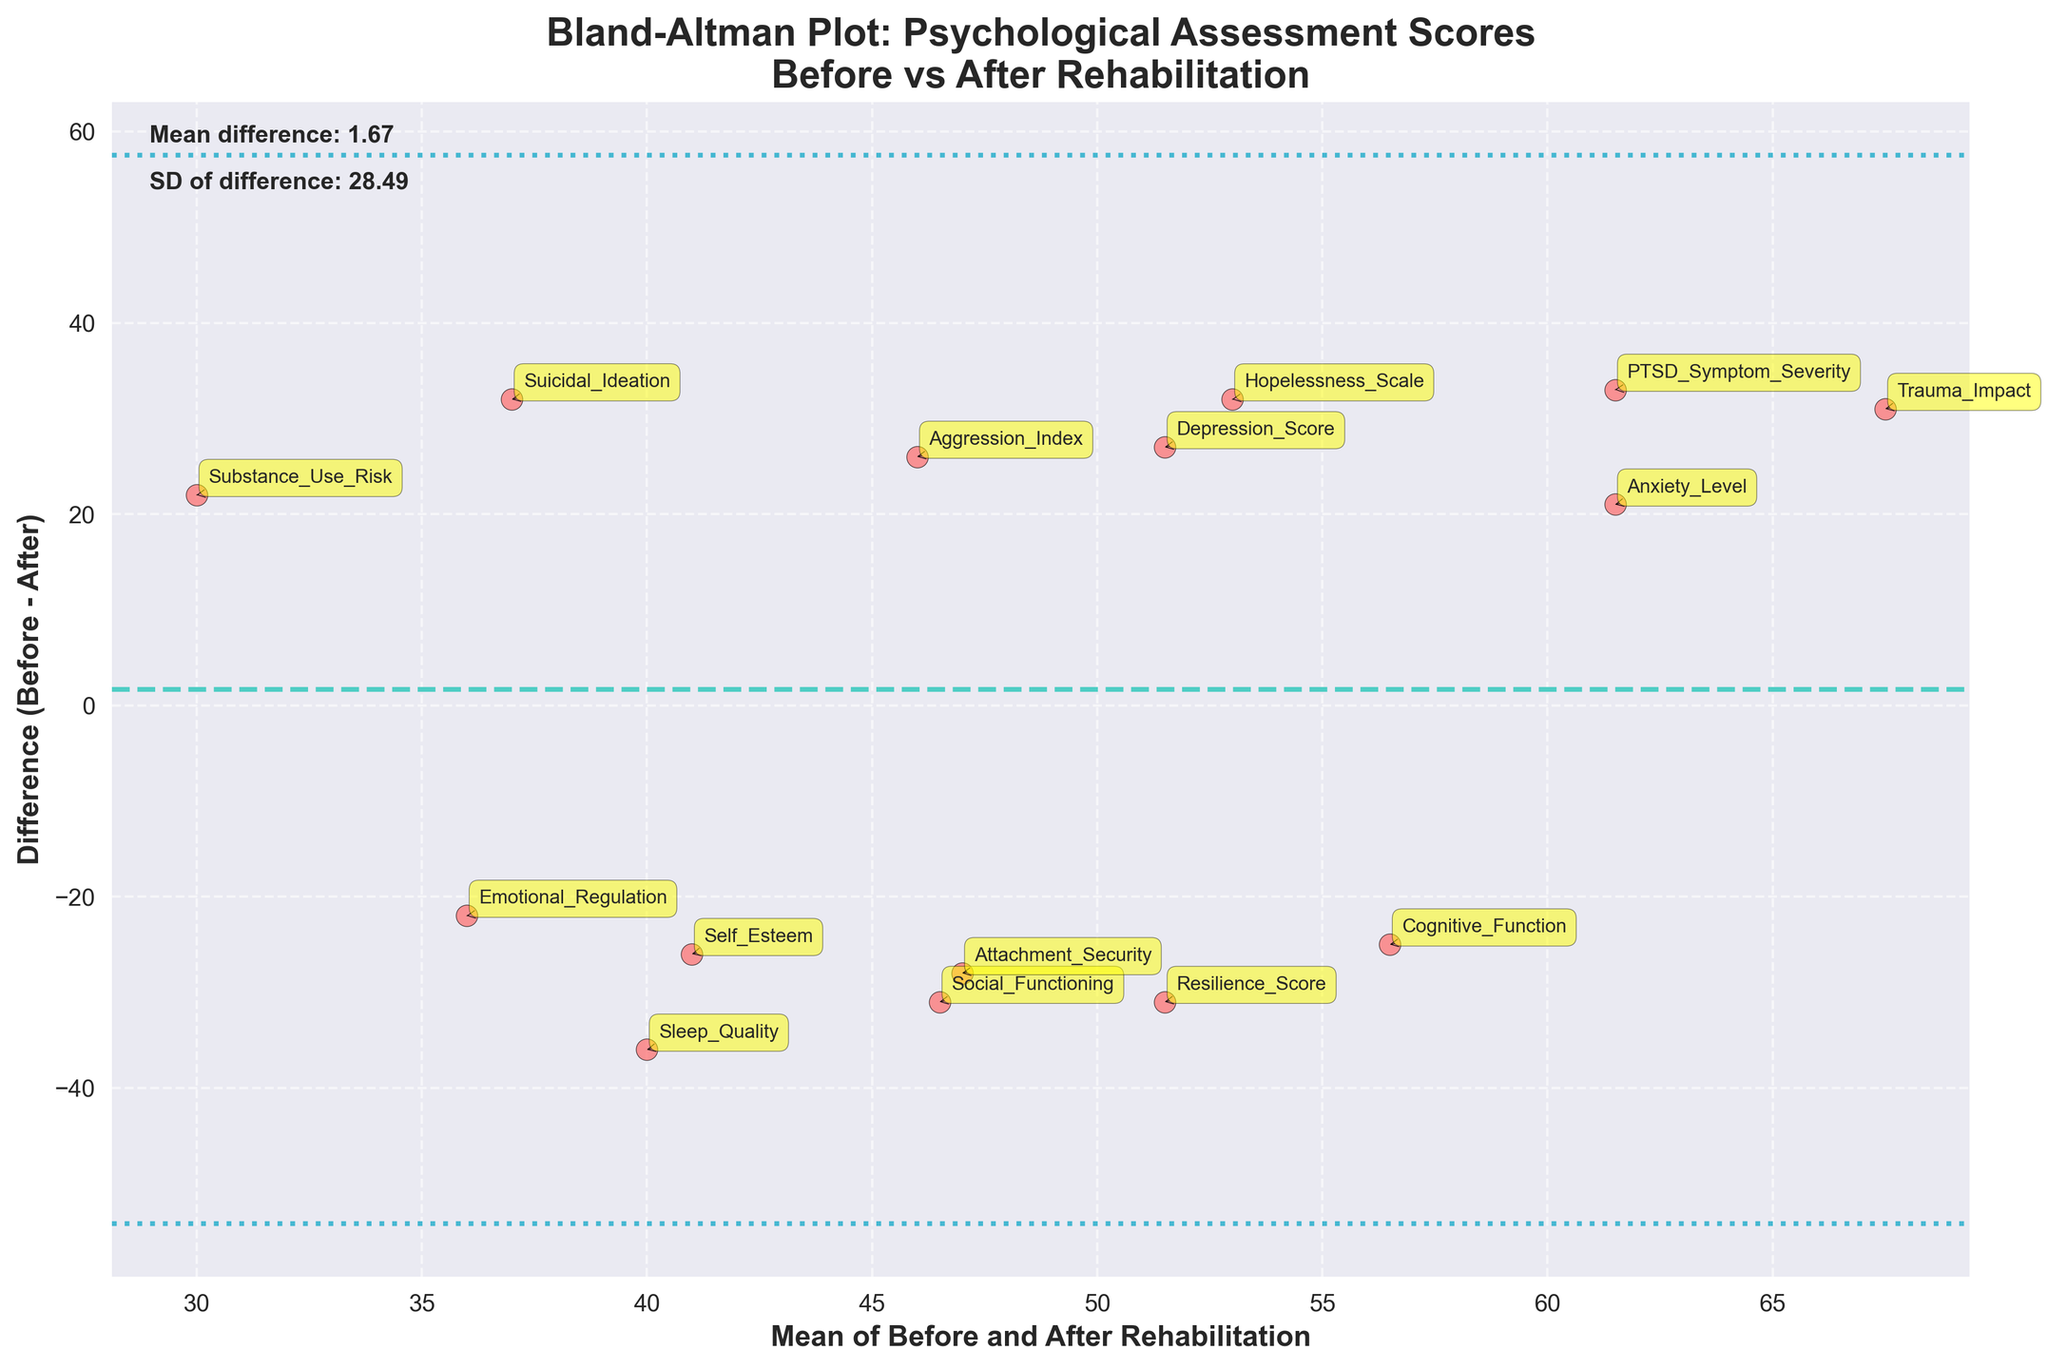What is the title of the plot? The title of the plot is found at the top of the figure. It is usually a summary of what the plot represents.
Answer: Bland-Altman Plot: Psychological Assessment Scores Before vs After Rehabilitation How many data points are plotted in the figure? To find out the number of data points, count the number of scatter points represented in the plot. Each point corresponds to an assessment type.
Answer: 15 What is the mean difference between the before and after rehabilitation scores? The mean difference is indicated by the horizontal dashed line and is also provided in the text on the plot.
Answer: Approximately 20.13 What are the boundaries of the 95% limits of agreement? The 95% limits of agreement are indicated by the dotted lines above and below the mean difference line. The specific values can be read from where these lines intersect the y-axis.
Answer: Approximately 50.25 and -9.98 Which assessment shows the largest improvement after rehabilitation? The largest improvement corresponds to the largest positive difference on the y-axis. Find the highest point below the mean difference line, which represents the largest reduction in score.
Answer: Suicidal Ideation Which assessment shows a worsening score after rehabilitation? A worsening score is indicated by a negative difference. Look for a point above the mean difference line, which indicates an increase in score after rehabilitation.
Answer: Social Functioning Are there any assessments whose scores almost did not change after rehabilitation? Scores that did not change much will be close to the y-axis value of zero. Look for points that are near the zero line on the y-axis.
Answer: Sleep Quality What does the red scatter point color and the black edge indicate? The scatter point colors and edges help to visually differentiate the points against the background. It helps to identify individual assessments easily.
Answer: Cosmetic design to improve readability How is the mean calculated in the plot? The mean is calculated by taking the average of the scores before and after rehabilitation for each assessment. (Before + After)/2
Answer: Average of before and after scores How is the difference calculated in the plot? The difference is calculated by subtracting the after rehabilitation score from the before rehabilitation score. Before - After
Answer: Before minus After Why are there text annotations next to each scatter point? Text annotations identify which assessment each scatter point corresponds to, aiding in interpretability and analysis.
Answer: To identify assessments 